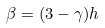Convert formula to latex. <formula><loc_0><loc_0><loc_500><loc_500>\beta = ( 3 - \gamma ) h</formula> 